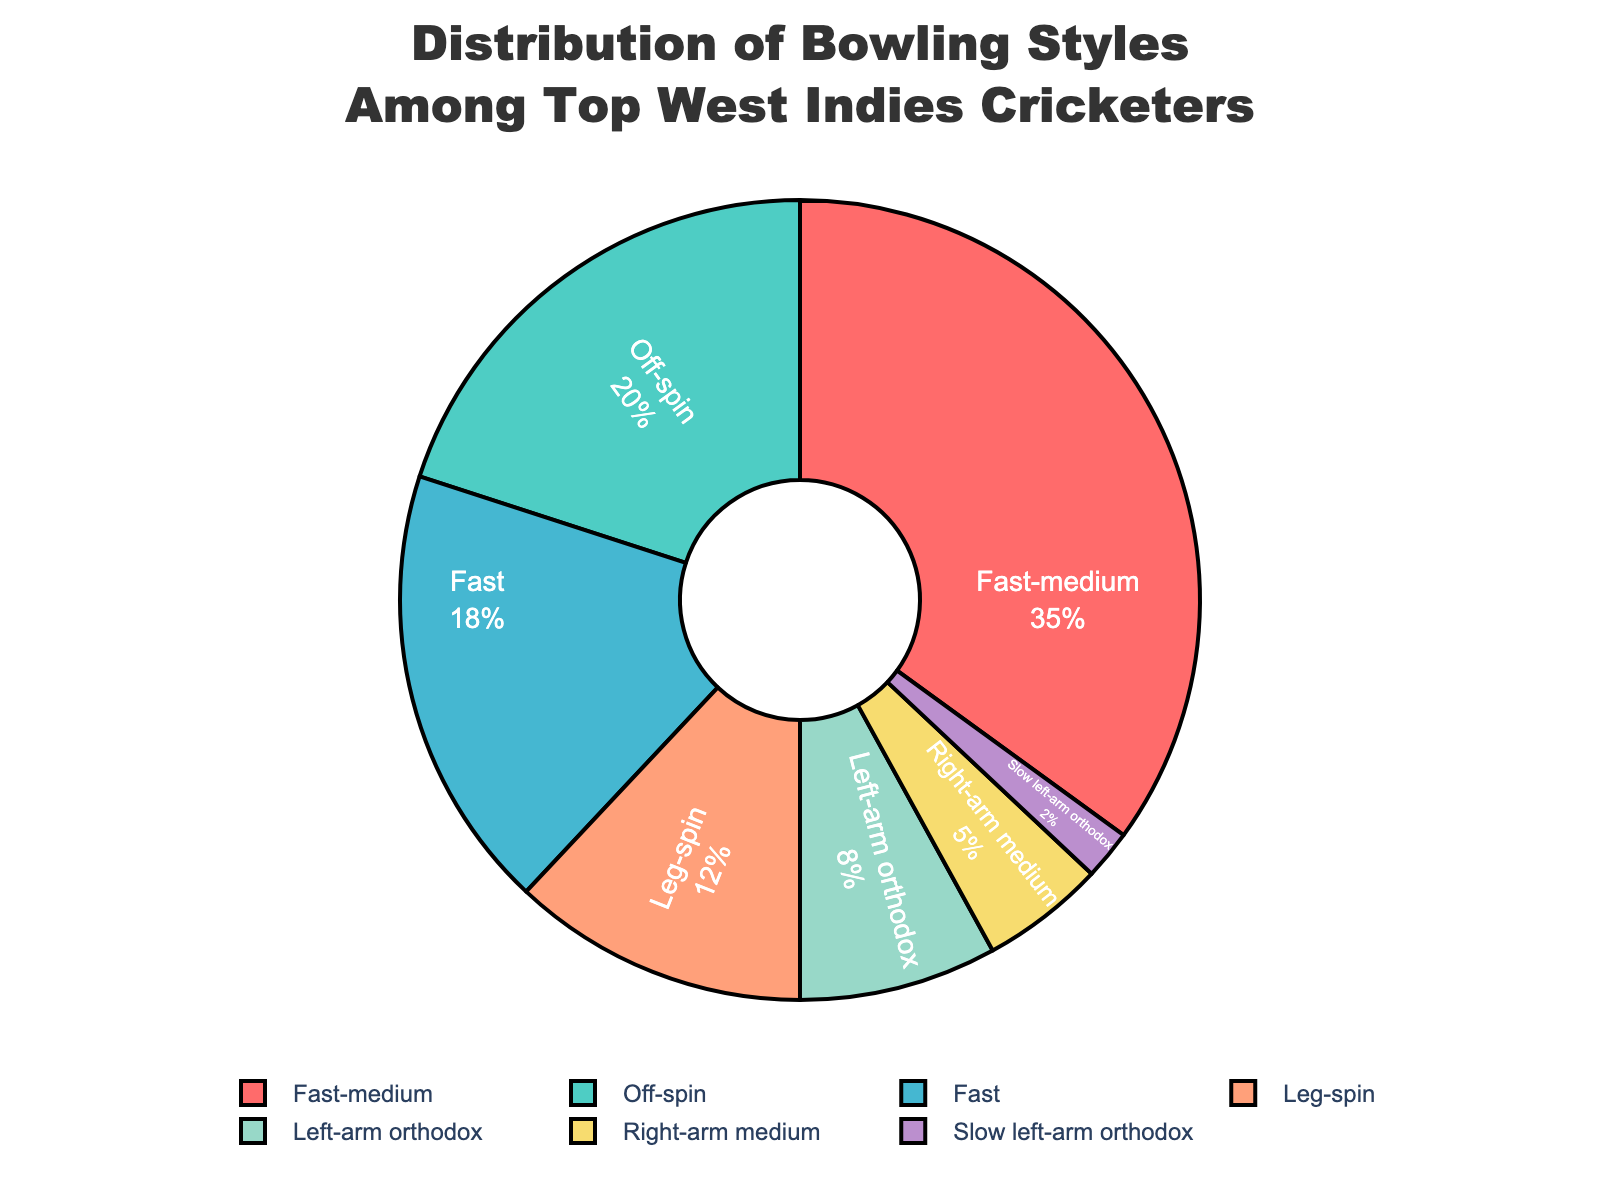Which bowling style is most common among top West Indies cricketers? The pie chart shows that the largest section, 35%, corresponds to the Fast-medium bowling style.
Answer: Fast-medium What is the combined percentage of spinners (Off-spin, Leg-spin, Left-arm orthodox, Slow left-arm orthodox) among the cricketers? Add the percentages of Off-spin (20%), Leg-spin (12%), Left-arm orthodox (8%), and Slow left-arm orthodox (2%): 20 + 12 + 8 + 2 = 42%
Answer: 42% How does the percentage of Fast bowlers compare to that of Right-arm medium bowlers? The chart indicates that Fast bowlers make up 18% while Right-arm medium bowlers make up 5%. 18% is greater than 5%.
Answer: 18% is greater than 5% What is the second most common bowling style? The second largest segment after Fast-medium (35%) is Off-spin, which has 20%.
Answer: Off-spin What percentage of bowlers use a medium pace bowling style (Fast-medium and Right-arm medium)? Add the percentages of Fast-medium (35%) and Right-arm medium (5%): 35 + 5 = 40%
Answer: 40% Which style is less common: Leg-spin or Slow left-arm orthodox? According to the pie chart, Leg-spin is 12% and Slow left-arm orthodox is 2%. Therefore, Slow left-arm orthodox is less common.
Answer: Slow left-arm orthodox What is the difference in percentage between the most and least common bowling styles? The most common is Fast-medium at 35%, and the least common is Slow left-arm orthodox at 2%. The difference is 35 - 2 = 33%
Answer: 33% By looking at the colors, which bowling style is represented by the light blue section? The light blue section represents Fast bowlers with a percentage of 18%.
Answer: Fast What is the total percentage of all medium pace bowlers? Sum the percentages of Fast-medium (35%) and Right-arm medium (5%): 35 + 5 = 40%
Answer: 40% Is the percentage of Off-spin bowlers greater than or equal to the combined percentage of Left-arm orthodox and Right-arm medium bowlers? Off-spin is 20%. The combined percentage of Left-arm orthodox (8%) and Right-arm medium (5%) is 8 + 5 = 13%. Therefore, 20% is greater than 13%.
Answer: Yes, 20% is greater 